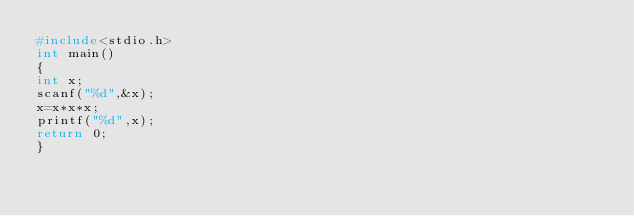Convert code to text. <code><loc_0><loc_0><loc_500><loc_500><_C_>#include<stdio.h>
int main()
{
int x;
scanf("%d",&x);
x=x*x*x;
printf("%d",x);
return 0;
}</code> 